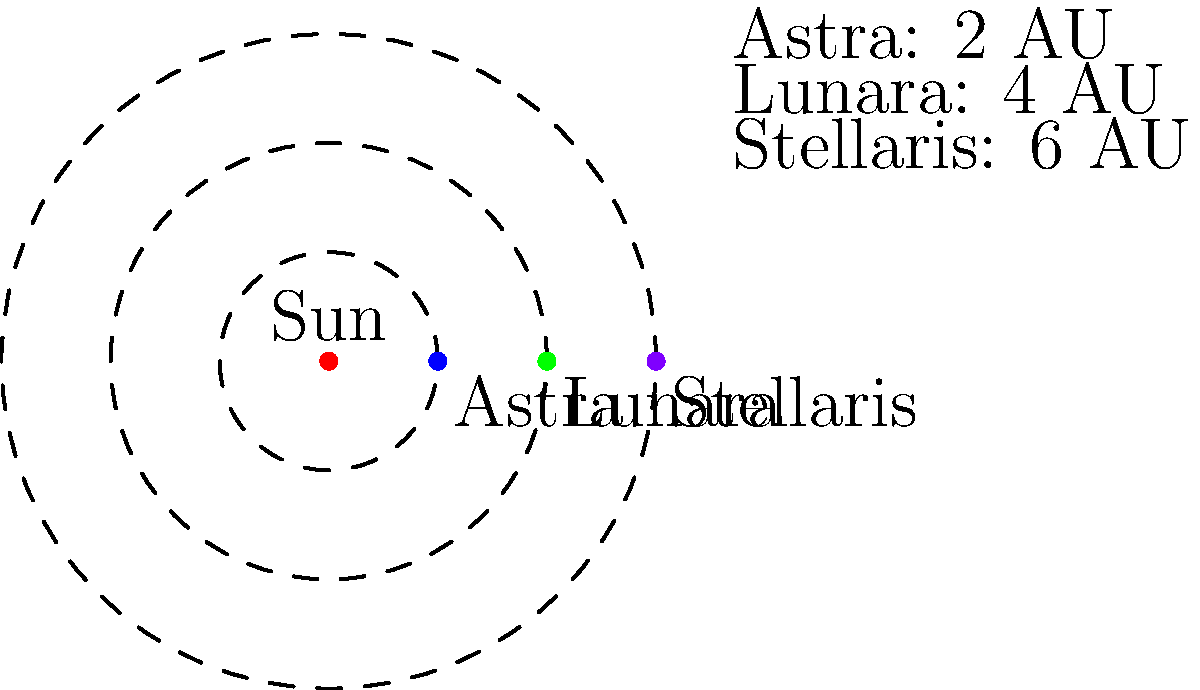In your fantasy novel's solar system, you've created three planets: Astra, Lunara, and Stellaris. Their distances from the central star are 2 AU, 4 AU, and 6 AU, respectively. If Astra's orbital period is 1 Earth year, calculate the orbital periods of Lunara and Stellaris in Earth years. (Assume Kepler's Third Law applies in this fictional system.) To solve this problem, we'll use Kepler's Third Law, which states that the square of the orbital period of a planet is directly proportional to the cube of the semi-major axis of its orbit.

Let's follow these steps:

1) Kepler's Third Law: $T^2 \propto a^3$, where $T$ is the orbital period and $a$ is the semi-major axis (distance from the star).

2) For Astra: $T_A = 1$ year, $a_A = 2$ AU

3) For any planet in this system: $\frac{T^2}{a^3} = \frac{T_A^2}{a_A^3} = \frac{1^2}{2^3} = \frac{1}{8}$

4) For Lunara:
   $\frac{T_L^2}{4^3} = \frac{1}{8}$
   $T_L^2 = 4^3 \cdot \frac{1}{8} = 8$
   $T_L = \sqrt{8} = 2\sqrt{2} \approx 2.83$ years

5) For Stellaris:
   $\frac{T_S^2}{6^3} = \frac{1}{8}$
   $T_S^2 = 6^3 \cdot \frac{1}{8} = 27$
   $T_S = \sqrt{27} = 3\sqrt{3} \approx 5.20$ years

Therefore, Lunara's orbital period is about 2.83 Earth years, and Stellaris's orbital period is about 5.20 Earth years.
Answer: Lunara: $2\sqrt{2}$ years, Stellaris: $3\sqrt{3}$ years 